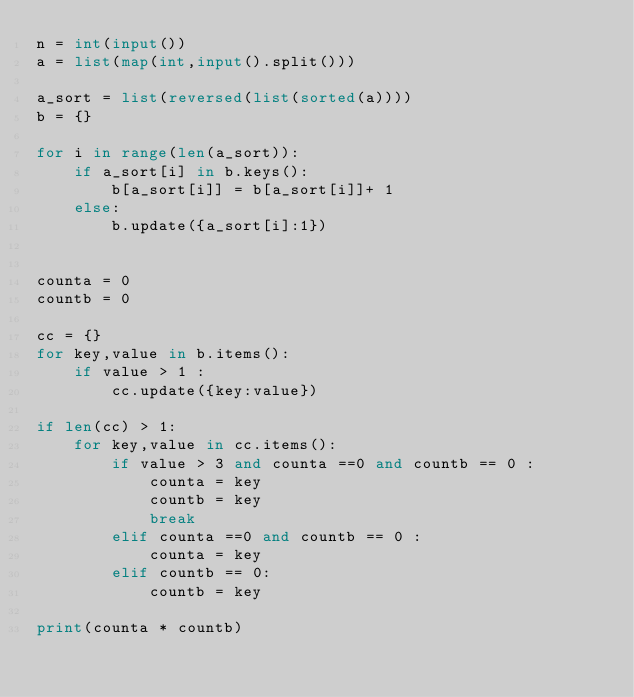<code> <loc_0><loc_0><loc_500><loc_500><_Python_>n = int(input())
a = list(map(int,input().split()))

a_sort = list(reversed(list(sorted(a))))
b = {}

for i in range(len(a_sort)):
    if a_sort[i] in b.keys():
        b[a_sort[i]] = b[a_sort[i]]+ 1
    else:
        b.update({a_sort[i]:1})


counta = 0
countb = 0

cc = {}
for key,value in b.items():
    if value > 1 :
        cc.update({key:value})
        
if len(cc) > 1:
    for key,value in cc.items():
        if value > 3 and counta ==0 and countb == 0 :
            counta = key
            countb = key
            break
        elif counta ==0 and countb == 0 :
            counta = key
        elif countb == 0:
            countb = key
            
print(counta * countb)
        </code> 